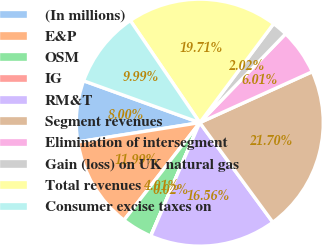Convert chart to OTSL. <chart><loc_0><loc_0><loc_500><loc_500><pie_chart><fcel>(In millions)<fcel>E&P<fcel>OSM<fcel>IG<fcel>RM&T<fcel>Segment revenues<fcel>Elimination of intersegment<fcel>Gain (loss) on UK natural gas<fcel>Total revenues<fcel>Consumer excise taxes on<nl><fcel>8.0%<fcel>11.99%<fcel>4.01%<fcel>0.02%<fcel>16.56%<fcel>21.7%<fcel>6.01%<fcel>2.02%<fcel>19.71%<fcel>9.99%<nl></chart> 